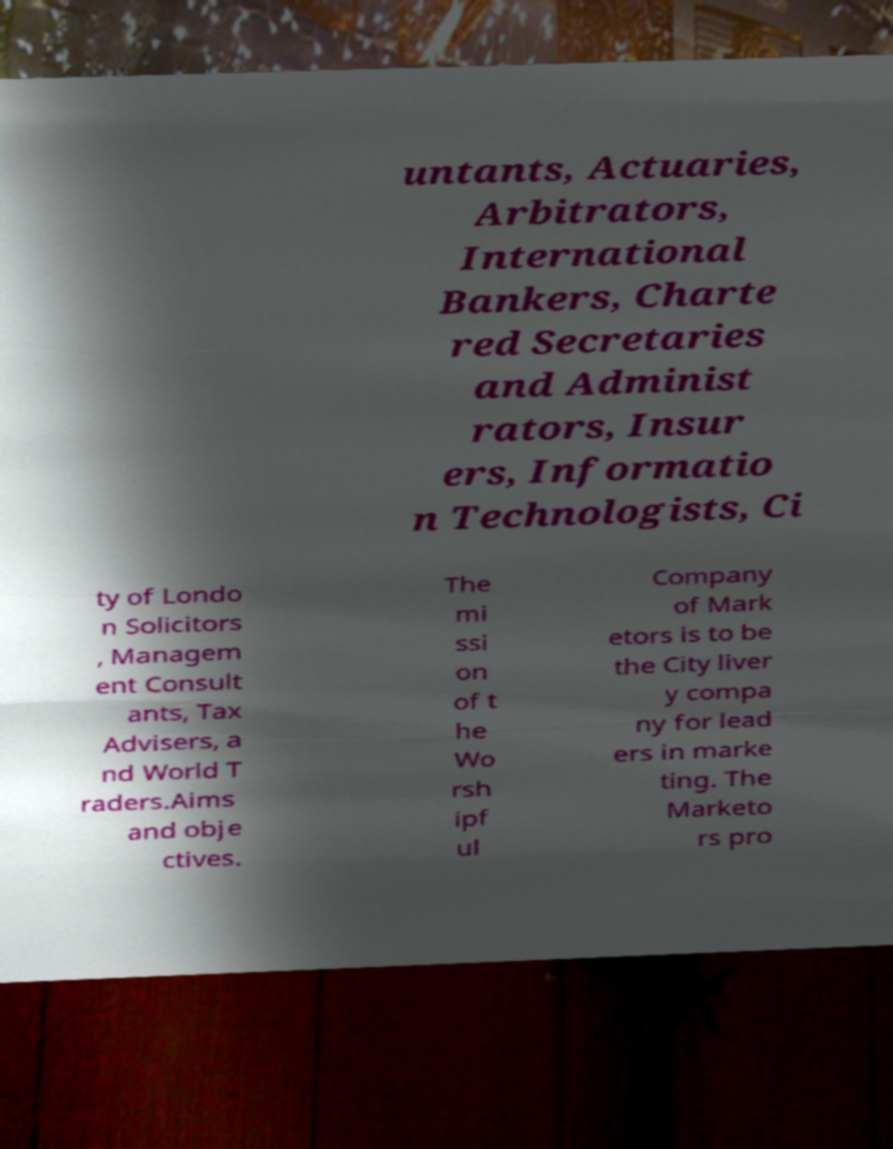Can you accurately transcribe the text from the provided image for me? untants, Actuaries, Arbitrators, International Bankers, Charte red Secretaries and Administ rators, Insur ers, Informatio n Technologists, Ci ty of Londo n Solicitors , Managem ent Consult ants, Tax Advisers, a nd World T raders.Aims and obje ctives. The mi ssi on of t he Wo rsh ipf ul Company of Mark etors is to be the City liver y compa ny for lead ers in marke ting. The Marketo rs pro 